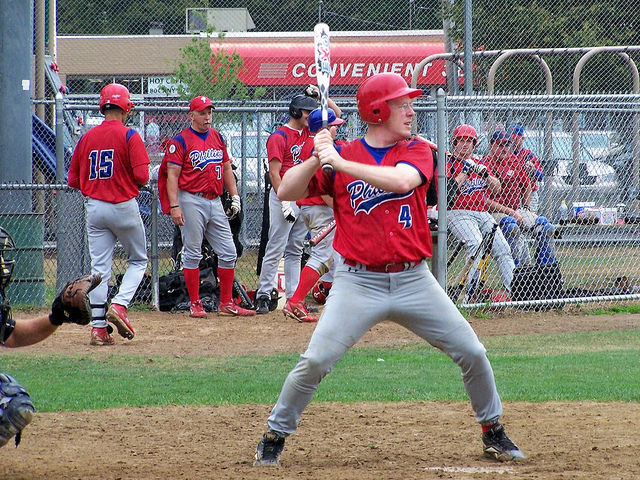Read and extract the text from this image. CONVENIENT 4 7 15 HOY 